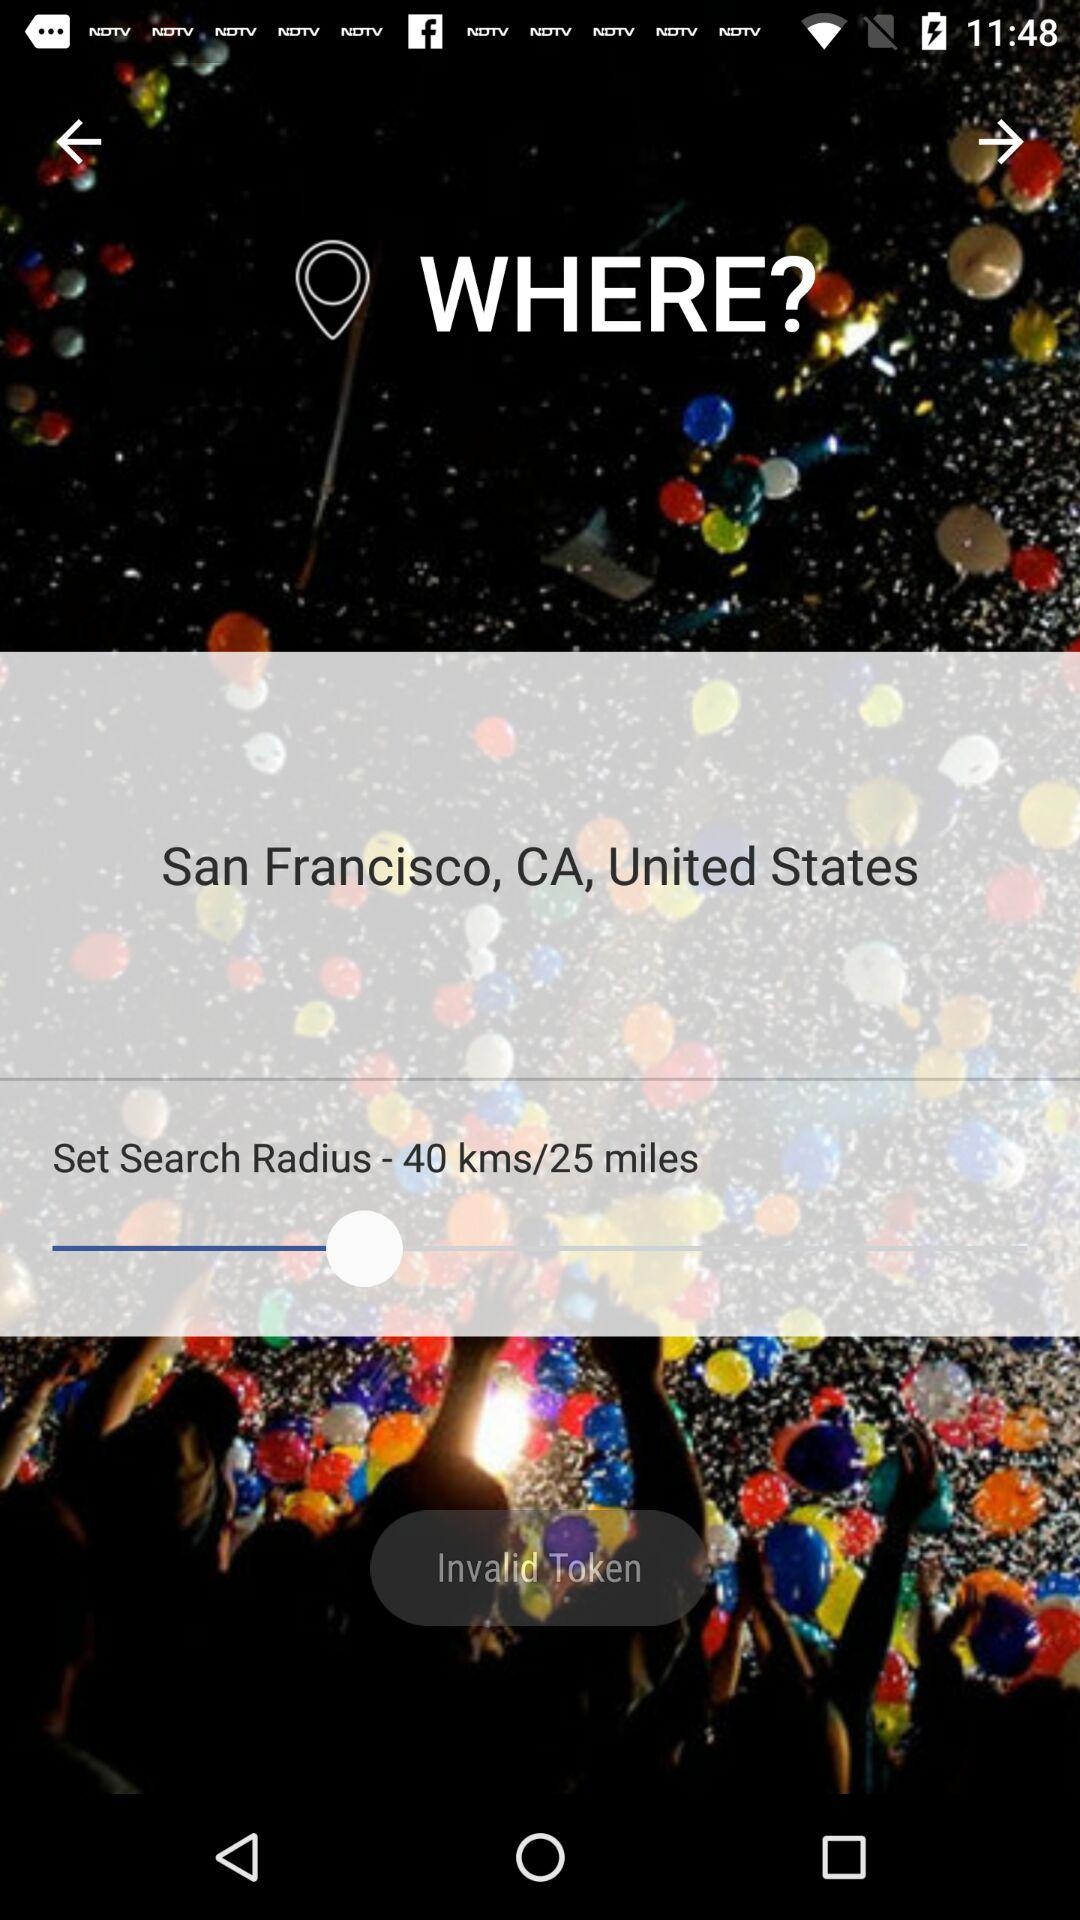How many kms is the search radius set to?
Answer the question using a single word or phrase. 40 